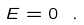Convert formula to latex. <formula><loc_0><loc_0><loc_500><loc_500>E = 0 \ .</formula> 